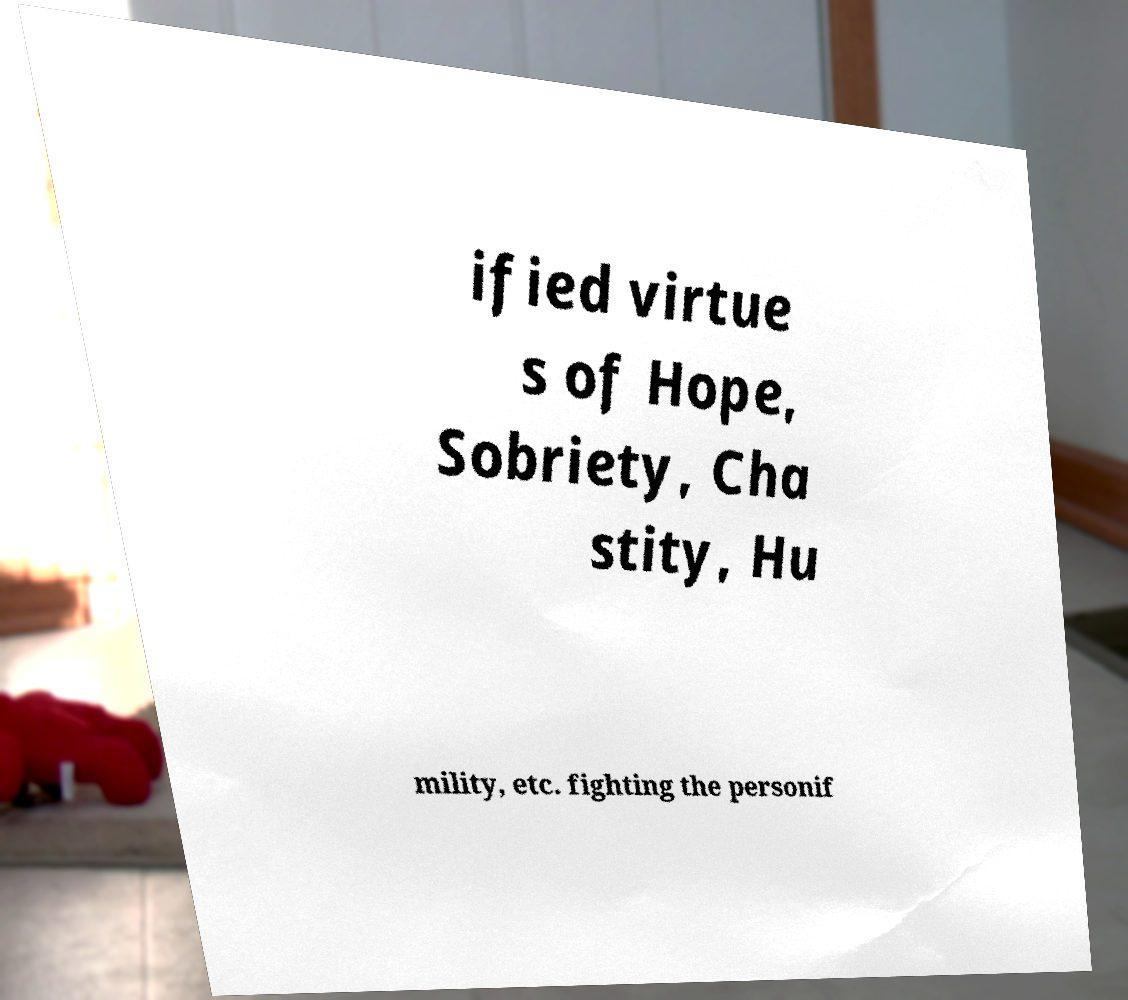I need the written content from this picture converted into text. Can you do that? ified virtue s of Hope, Sobriety, Cha stity, Hu mility, etc. fighting the personif 